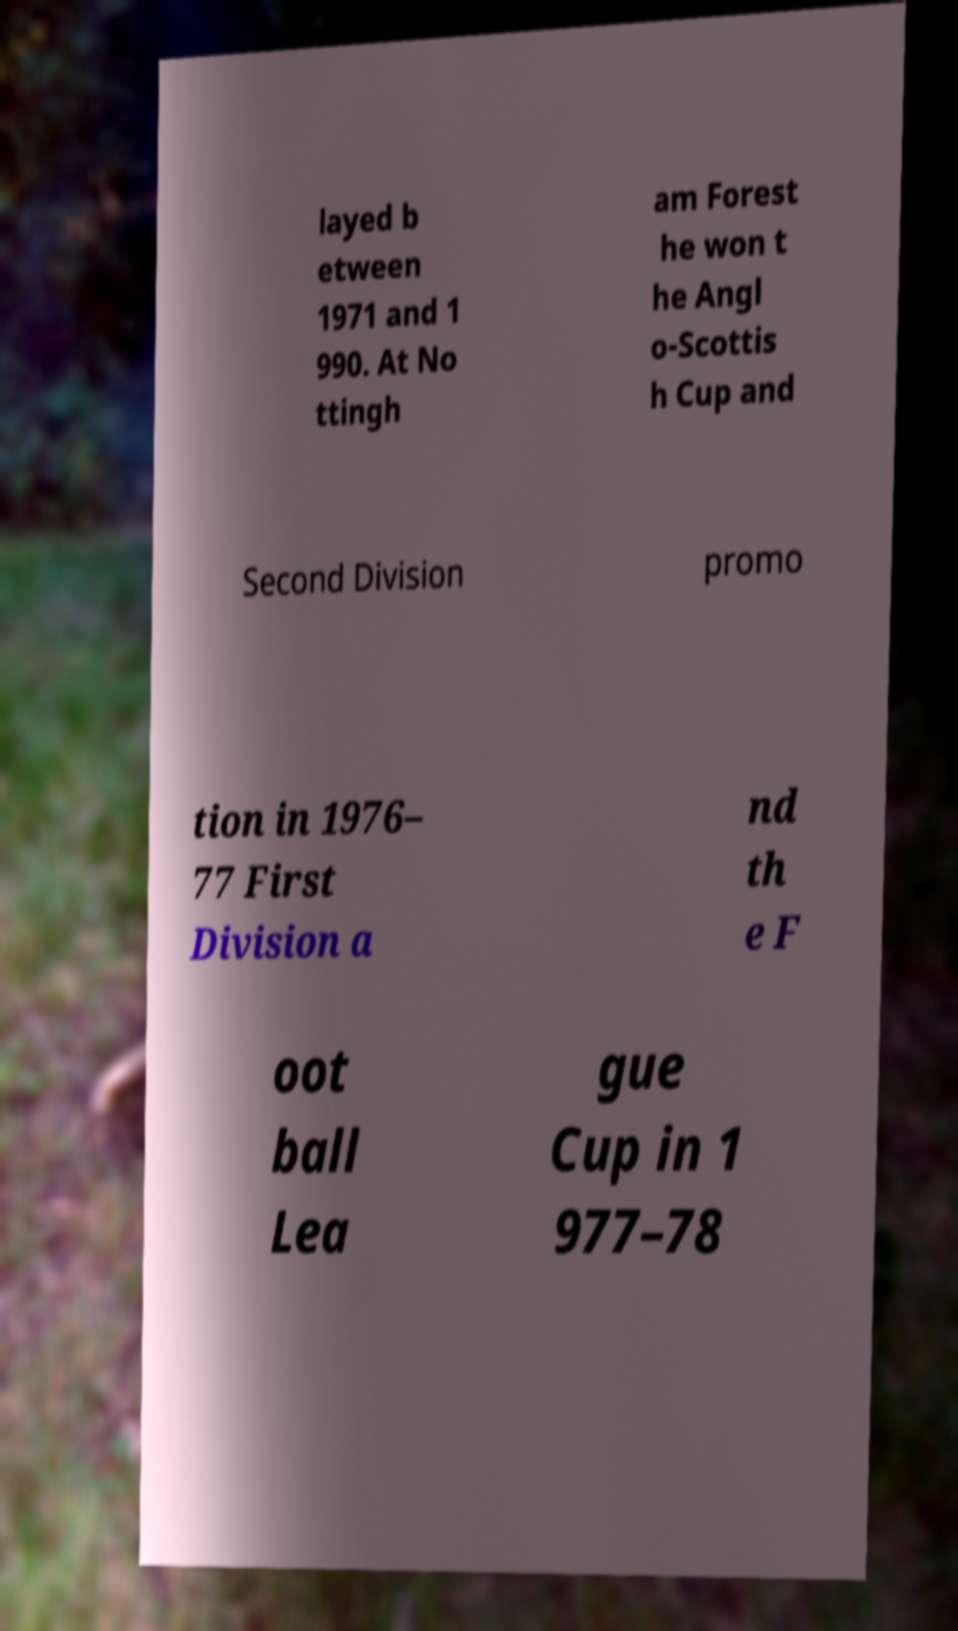Could you extract and type out the text from this image? layed b etween 1971 and 1 990. At No ttingh am Forest he won t he Angl o-Scottis h Cup and Second Division promo tion in 1976– 77 First Division a nd th e F oot ball Lea gue Cup in 1 977–78 